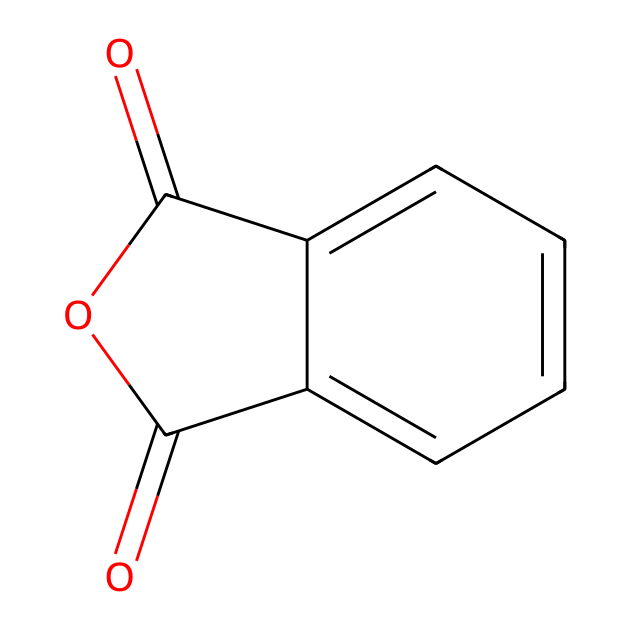What is the name of the chemical represented by the SMILES? The SMILES corresponds to a compound where the structure contains phthalic anhydride, as indicated by the presence of the anhydride functional groups (the two carbonyl groups adjacent to an oxygen atom in its cyclic structure).
Answer: phthalic anhydride How many carbon atoms are in this chemical structure? By analyzing the SMILES, we can identify the carbon atoms present. The structure contains six carbon atoms that are part of the aromatic ring and two more from the anhydride part, totaling eight.
Answer: eight What type of functional groups are present in phthalic anhydride? The structure shows two carbonyl groups (C=O) adjacent to an oxygen which indicates the presence of an anhydride functional group.
Answer: anhydride Is phthalic anhydride a solid or a liquid at room temperature? Common knowledge about phthalic anhydride tells us that it typically exists as a solid, particularly at room temperature, due to its relatively high melting point.
Answer: solid What is the degree of unsaturation in phthalic anhydride? The degree of unsaturation can be determined through the structure. The presence of the aromatic ring and the anhydride gives a total of four degrees of unsaturation, accounting for the double bonds and rings.
Answer: four Does phthalic anhydride have a double bond in its structure? Yes, analyzing the structure (both in SMILES and visual), we can see that there are carbon=carbon and carbon=oxygen double bonds present in the compound.
Answer: yes 